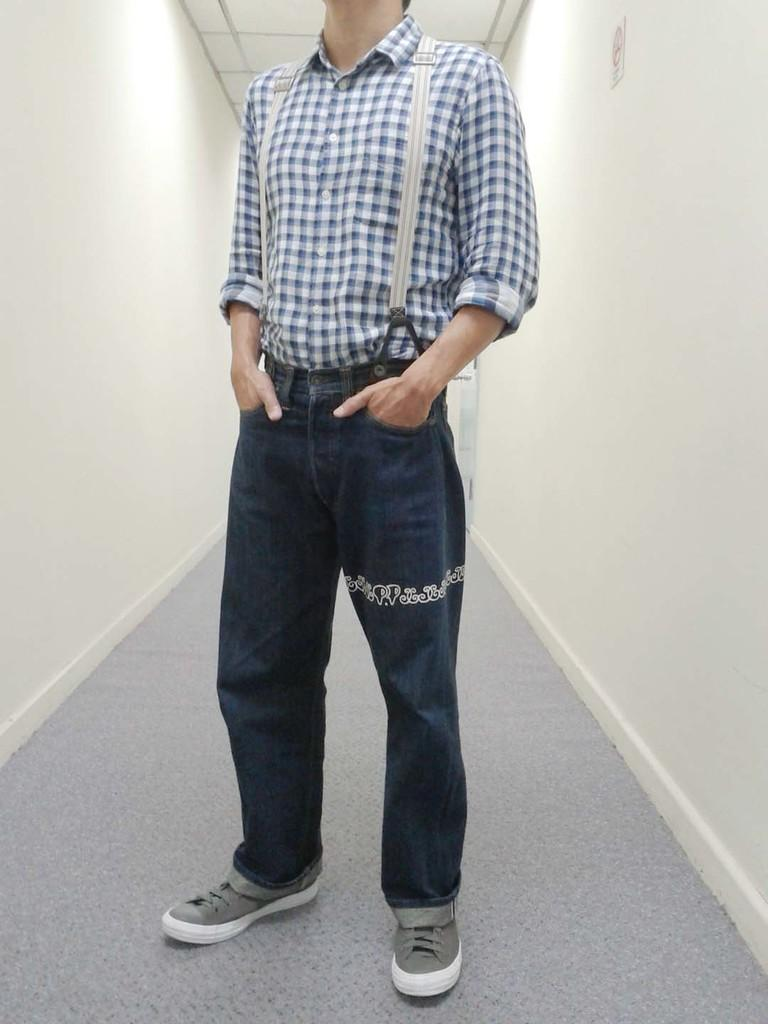Who or what is present in the image? There is a person in the image. What is the person doing in the image? The person is standing on the floor. What type of paper is the person holding in the image? There is no paper present in the image; the person is simply standing on the floor. 